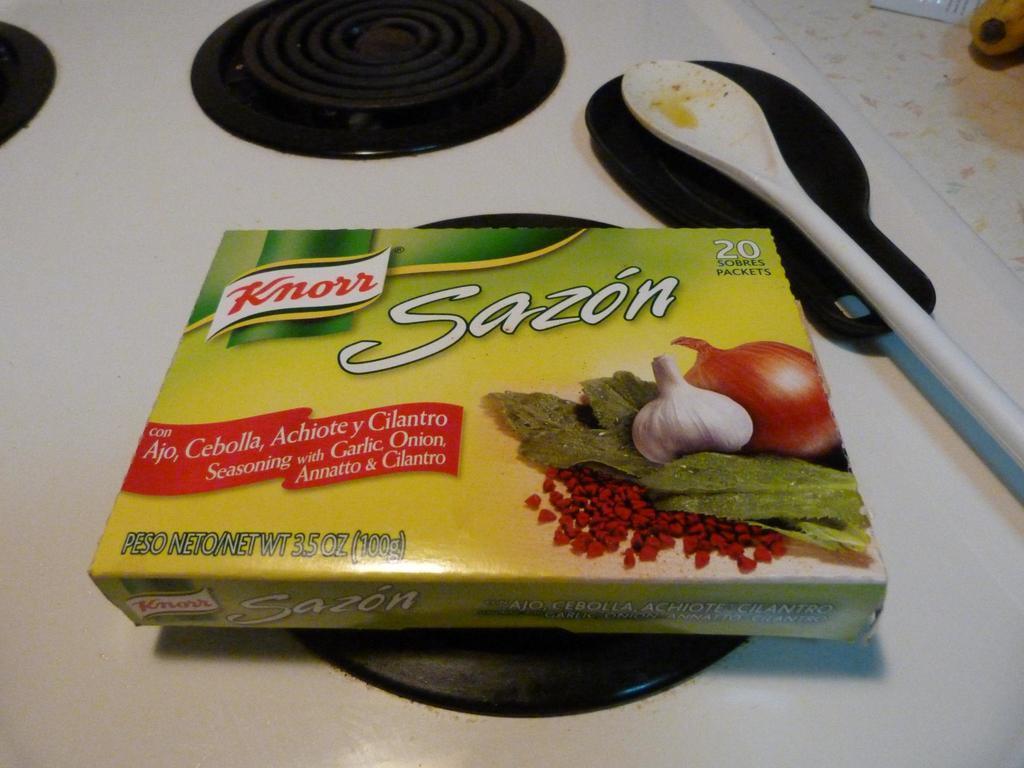Describe this image in one or two sentences. There is a knorr soup box on a table. There is a spoon and a plate on the table. 